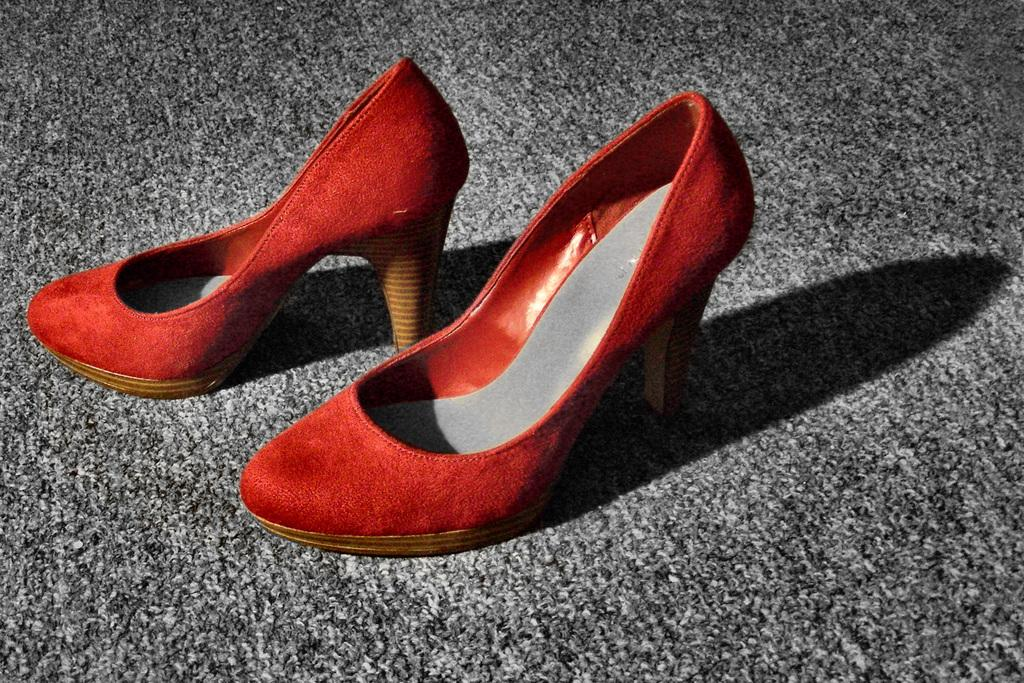What type of object is present in the image? There is footwear in the image. Where is the footwear located? The footwear is placed on a surface. How many sisters are depicted wearing the footwear in the image? There are no people, including sisters, present in the image; only footwear is visible. 